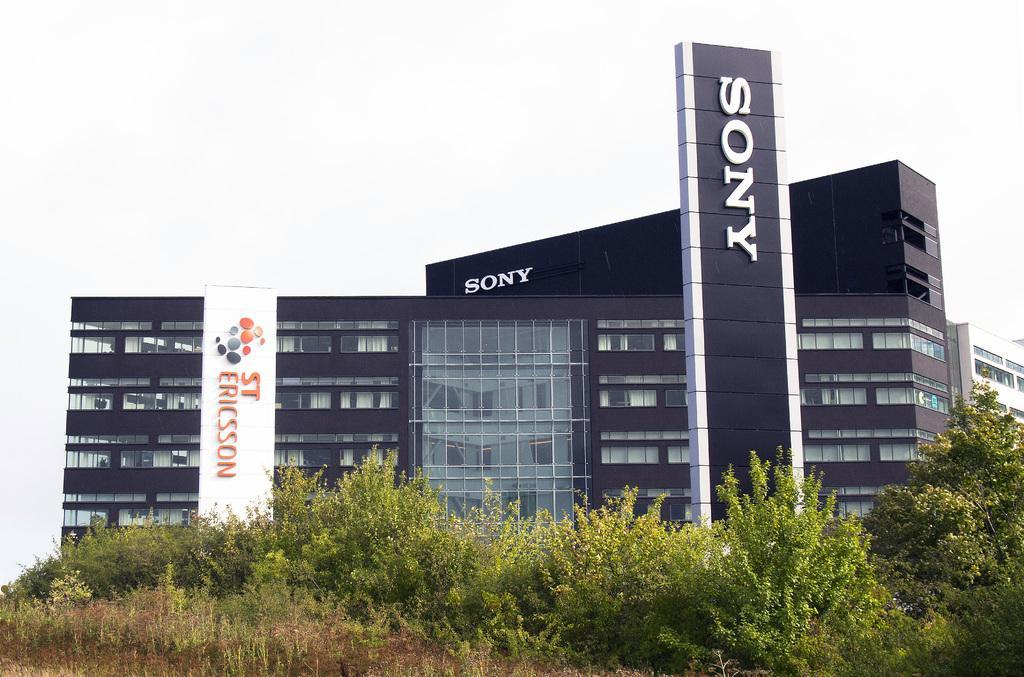In one or two sentences, can you explain what this image depicts? In this image I can see few trees which are green and brown in color and a building which is black and white in color. In the background I can see another building which is white in color and the sky. 